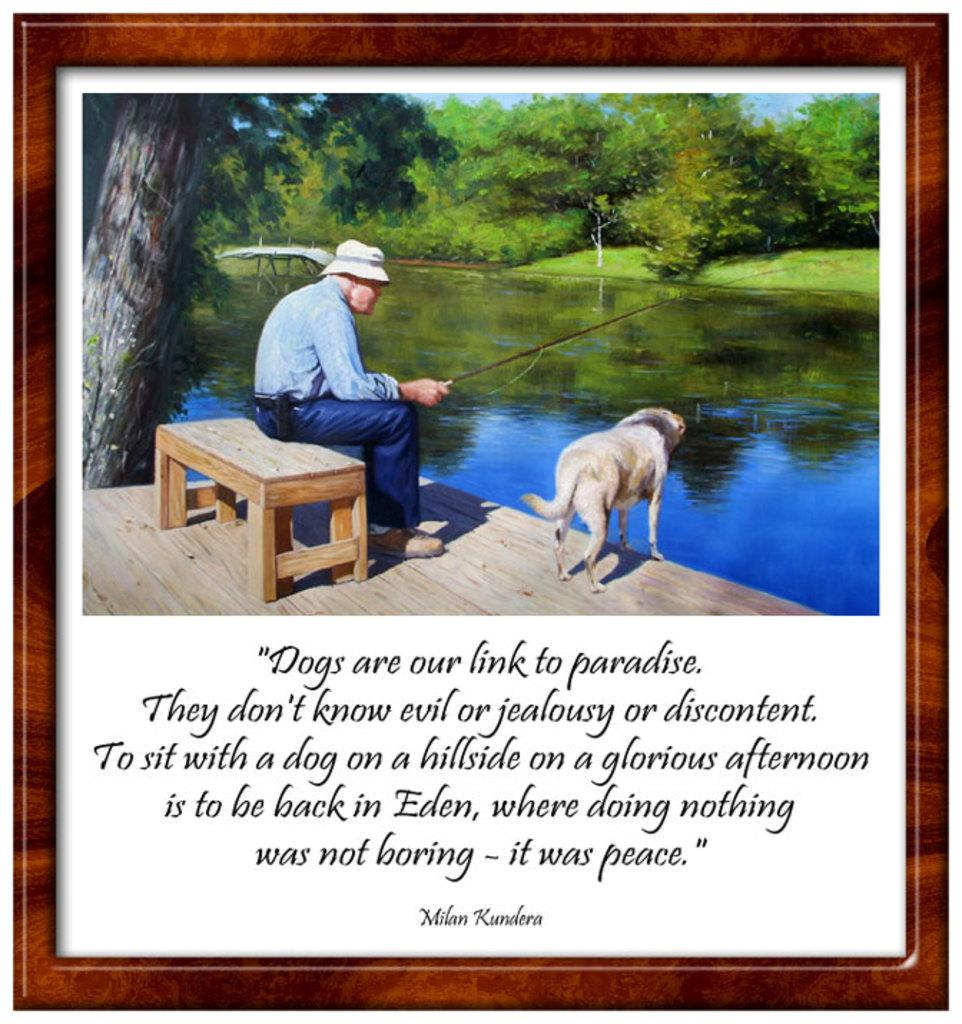<image>
Describe the image concisely. A photo and saying about dogs by Milan Kundera. 